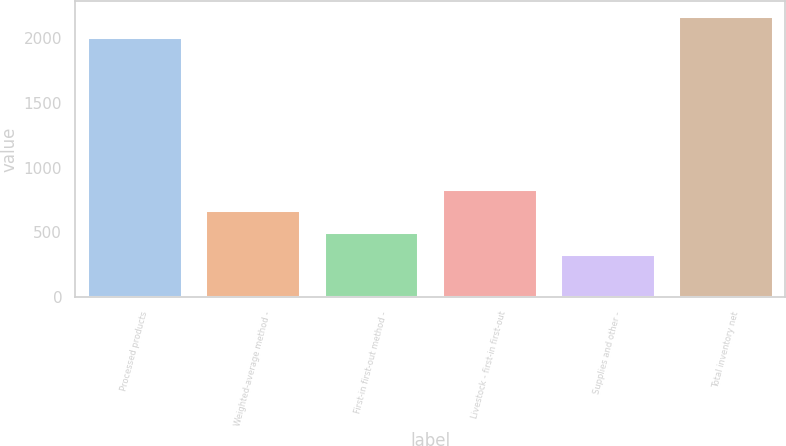<chart> <loc_0><loc_0><loc_500><loc_500><bar_chart><fcel>Processed products<fcel>Weighted-average method -<fcel>First-in first-out method -<fcel>Livestock - first-in first-out<fcel>Supplies and other -<fcel>Total inventory net<nl><fcel>2009<fcel>669.8<fcel>502.4<fcel>837.2<fcel>335<fcel>2176.4<nl></chart> 